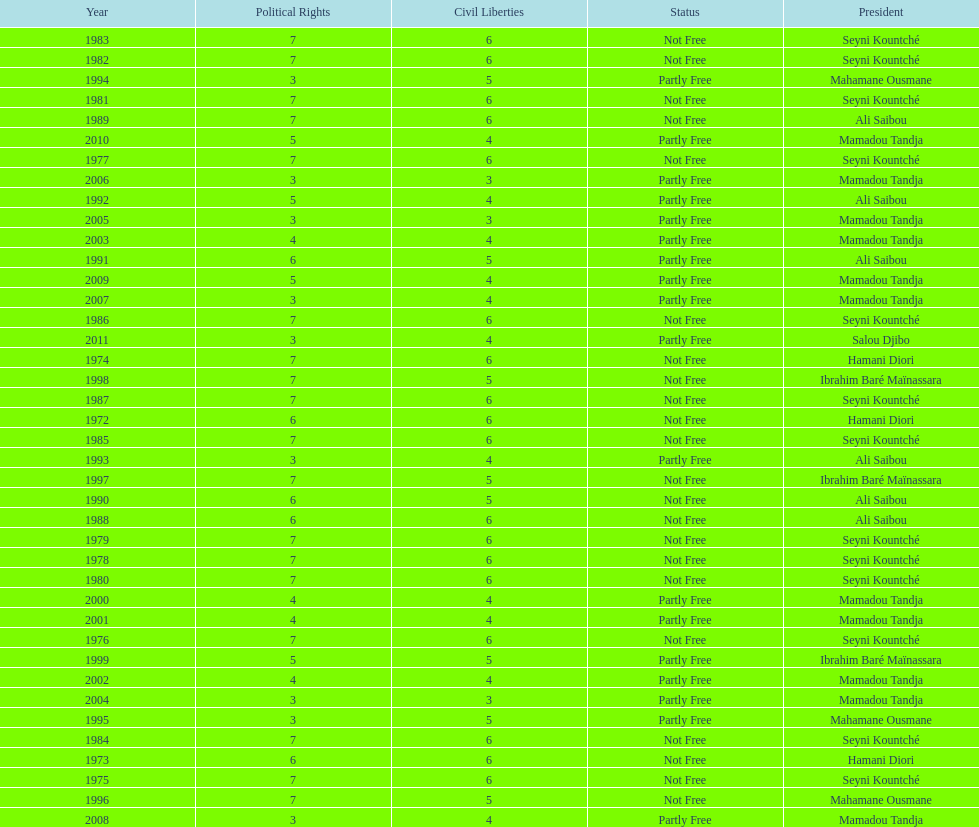Who is the next president listed after hamani diori in the year 1974? Seyni Kountché. 